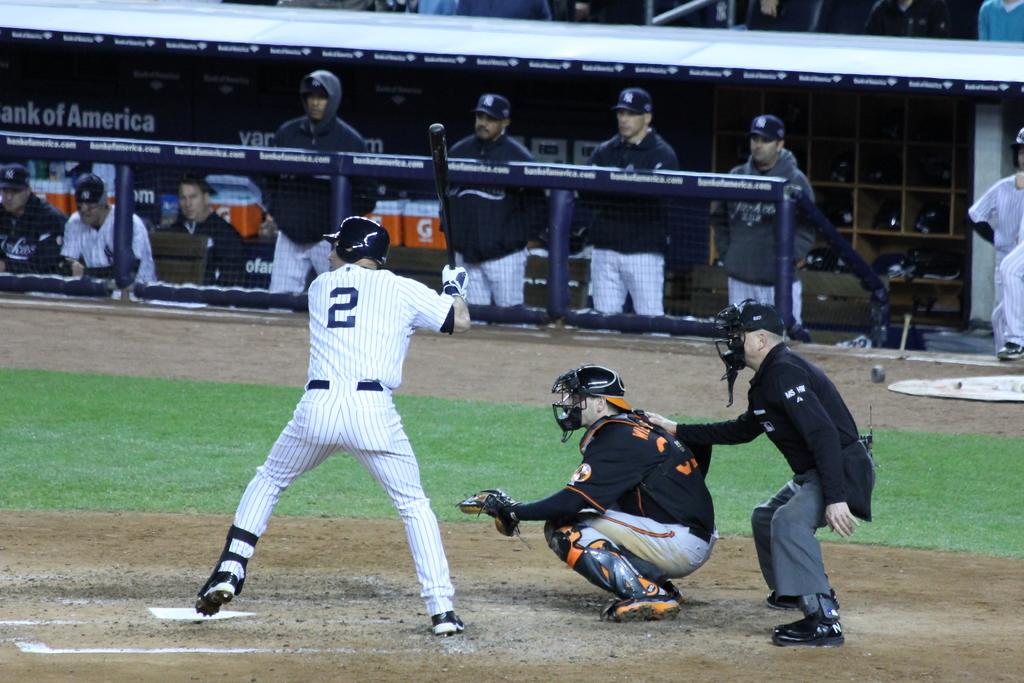What number is on the batter?
Offer a very short reply. 2. 